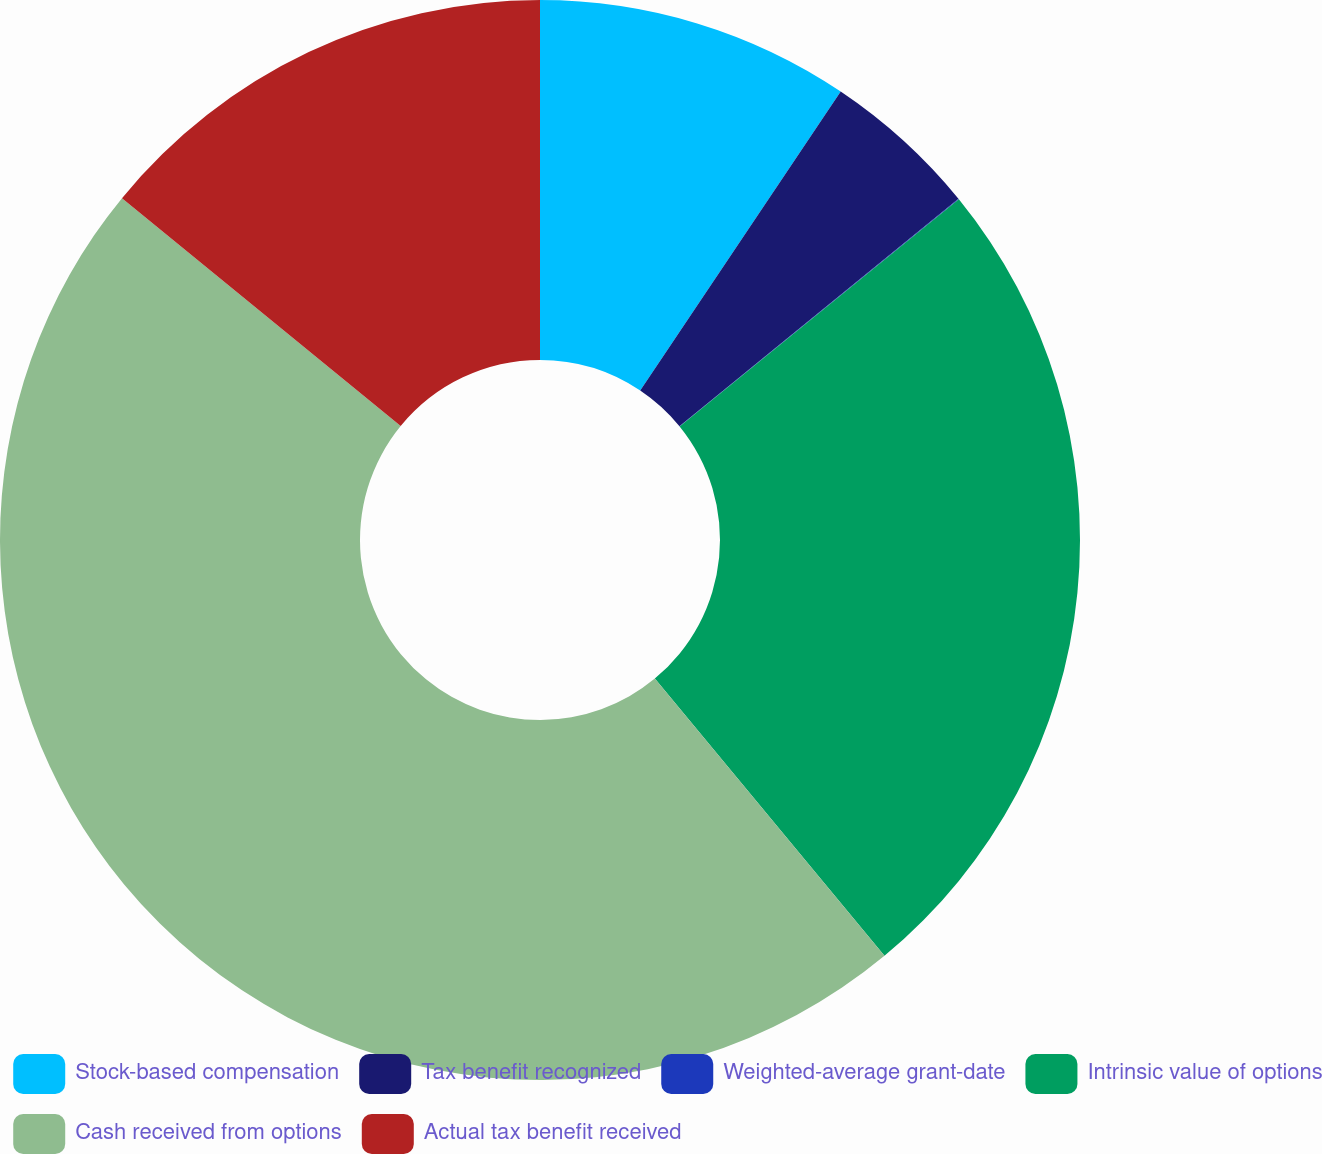<chart> <loc_0><loc_0><loc_500><loc_500><pie_chart><fcel>Stock-based compensation<fcel>Tax benefit recognized<fcel>Weighted-average grant-date<fcel>Intrinsic value of options<fcel>Cash received from options<fcel>Actual tax benefit received<nl><fcel>9.4%<fcel>4.71%<fcel>0.02%<fcel>24.86%<fcel>46.92%<fcel>14.09%<nl></chart> 